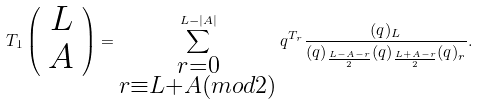<formula> <loc_0><loc_0><loc_500><loc_500>T _ { 1 } \left ( \begin{array} { c } L \\ A \end{array} \right ) = \sum _ { \substack { r = 0 \\ r \equiv L + A ( m o d 2 ) } } ^ { L - | A | } q ^ { T _ { r } } \frac { ( q ) _ { L } } { ( q ) _ { \frac { L - A - r } { 2 } } ( q ) _ { \frac { L + A - r } { 2 } } ( q ) _ { r } } .</formula> 